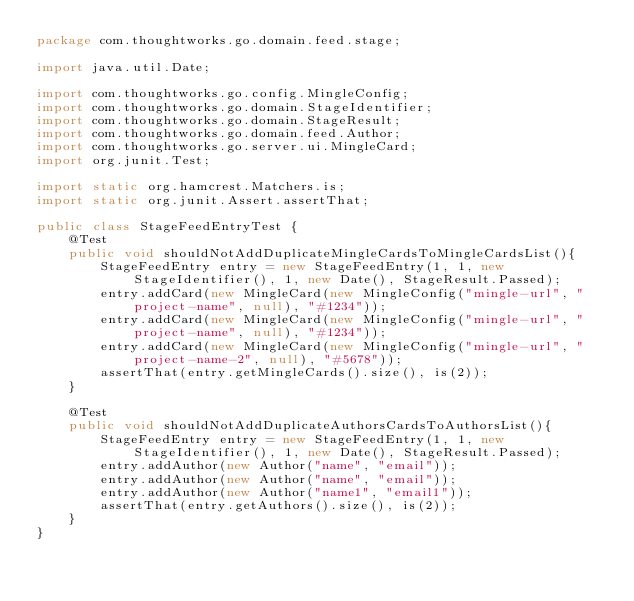<code> <loc_0><loc_0><loc_500><loc_500><_Java_>package com.thoughtworks.go.domain.feed.stage;

import java.util.Date;

import com.thoughtworks.go.config.MingleConfig;
import com.thoughtworks.go.domain.StageIdentifier;
import com.thoughtworks.go.domain.StageResult;
import com.thoughtworks.go.domain.feed.Author;
import com.thoughtworks.go.server.ui.MingleCard;
import org.junit.Test;

import static org.hamcrest.Matchers.is;
import static org.junit.Assert.assertThat;

public class StageFeedEntryTest {
    @Test
    public void shouldNotAddDuplicateMingleCardsToMingleCardsList(){
        StageFeedEntry entry = new StageFeedEntry(1, 1, new StageIdentifier(), 1, new Date(), StageResult.Passed);
        entry.addCard(new MingleCard(new MingleConfig("mingle-url", "project-name", null), "#1234"));
        entry.addCard(new MingleCard(new MingleConfig("mingle-url", "project-name", null), "#1234"));
        entry.addCard(new MingleCard(new MingleConfig("mingle-url", "project-name-2", null), "#5678"));
        assertThat(entry.getMingleCards().size(), is(2));
    }

    @Test
    public void shouldNotAddDuplicateAuthorsCardsToAuthorsList(){
        StageFeedEntry entry = new StageFeedEntry(1, 1, new StageIdentifier(), 1, new Date(), StageResult.Passed);
        entry.addAuthor(new Author("name", "email"));
        entry.addAuthor(new Author("name", "email"));
        entry.addAuthor(new Author("name1", "email1"));
        assertThat(entry.getAuthors().size(), is(2));
    }
}
</code> 